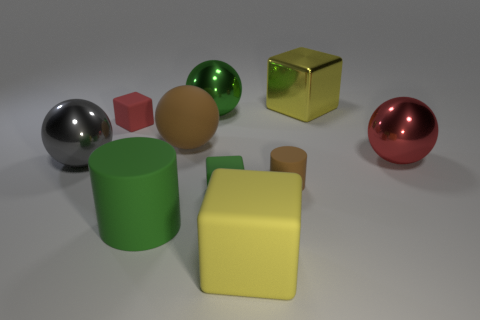What is the shape of the big yellow object in front of the large yellow cube that is on the right side of the brown rubber object in front of the big gray object?
Make the answer very short. Cube. What material is the large sphere that is in front of the large brown matte object and to the left of the red sphere?
Your response must be concise. Metal. Does the brown object in front of the red metal ball have the same size as the big brown matte ball?
Your answer should be compact. No. Is there any other thing that is the same size as the yellow shiny cube?
Provide a short and direct response. Yes. Are there more green metallic things to the right of the tiny brown rubber object than small rubber blocks that are behind the metal block?
Offer a very short reply. No. There is a object that is right of the yellow block to the right of the brown rubber thing that is in front of the big red metal thing; what color is it?
Ensure brevity in your answer.  Red. Does the small object on the right side of the yellow matte block have the same color as the metal cube?
Make the answer very short. No. How many other objects are the same color as the big cylinder?
Provide a succinct answer. 2. What number of things are tiny gray matte balls or small rubber objects?
Make the answer very short. 3. How many things are yellow metallic objects or objects in front of the tiny cylinder?
Your response must be concise. 4. 